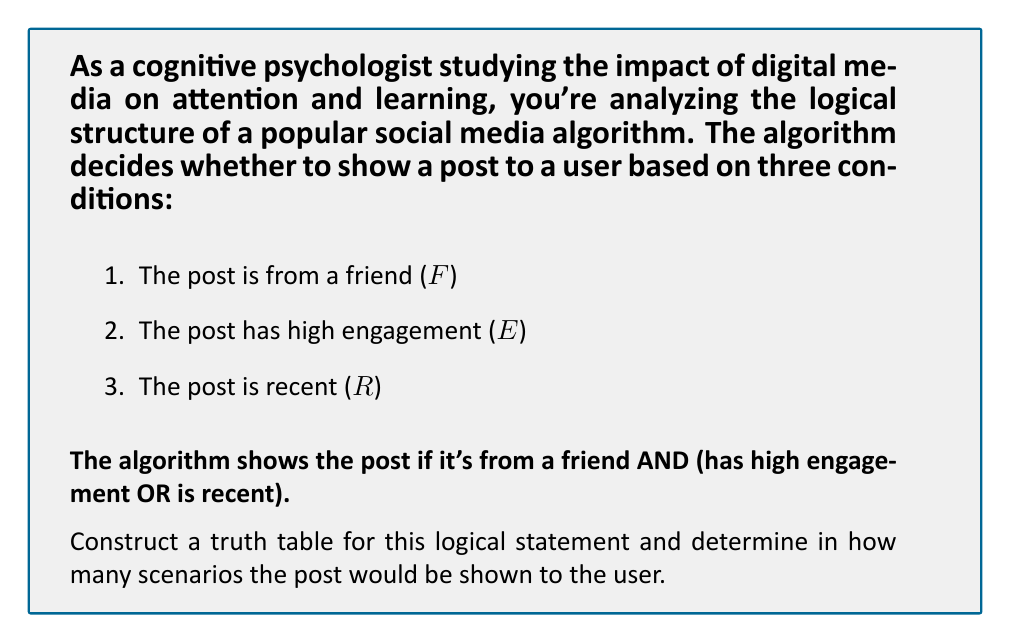Could you help me with this problem? Let's approach this step-by-step:

1) First, we need to translate the given conditions into a logical expression:

   $F \land (E \lor R)$

2) Now, let's create a truth table. We have 3 variables ($F$, $E$, and $R$), so our table will have $2^3 = 8$ rows.

3) Let's construct the table:

   $$
   \begin{array}{|c|c|c|c|c|c|}
   \hline
   F & E & R & E \lor R & F \land (E \lor R) \\
   \hline
   T & T & T & T & T \\
   T & T & F & T & T \\
   T & F & T & T & T \\
   T & F & F & F & F \\
   F & T & T & T & F \\
   F & T & F & T & F \\
   F & F & T & T & F \\
   F & F & F & F & F \\
   \hline
   \end{array}
   $$

4) To determine in how many scenarios the post would be shown, we count the number of 'T' (True) results in the final column.

5) From the table, we can see that there are 3 'T' results in the final column.

Therefore, there are 3 scenarios where the post would be shown to the user.
Answer: 3 scenarios 